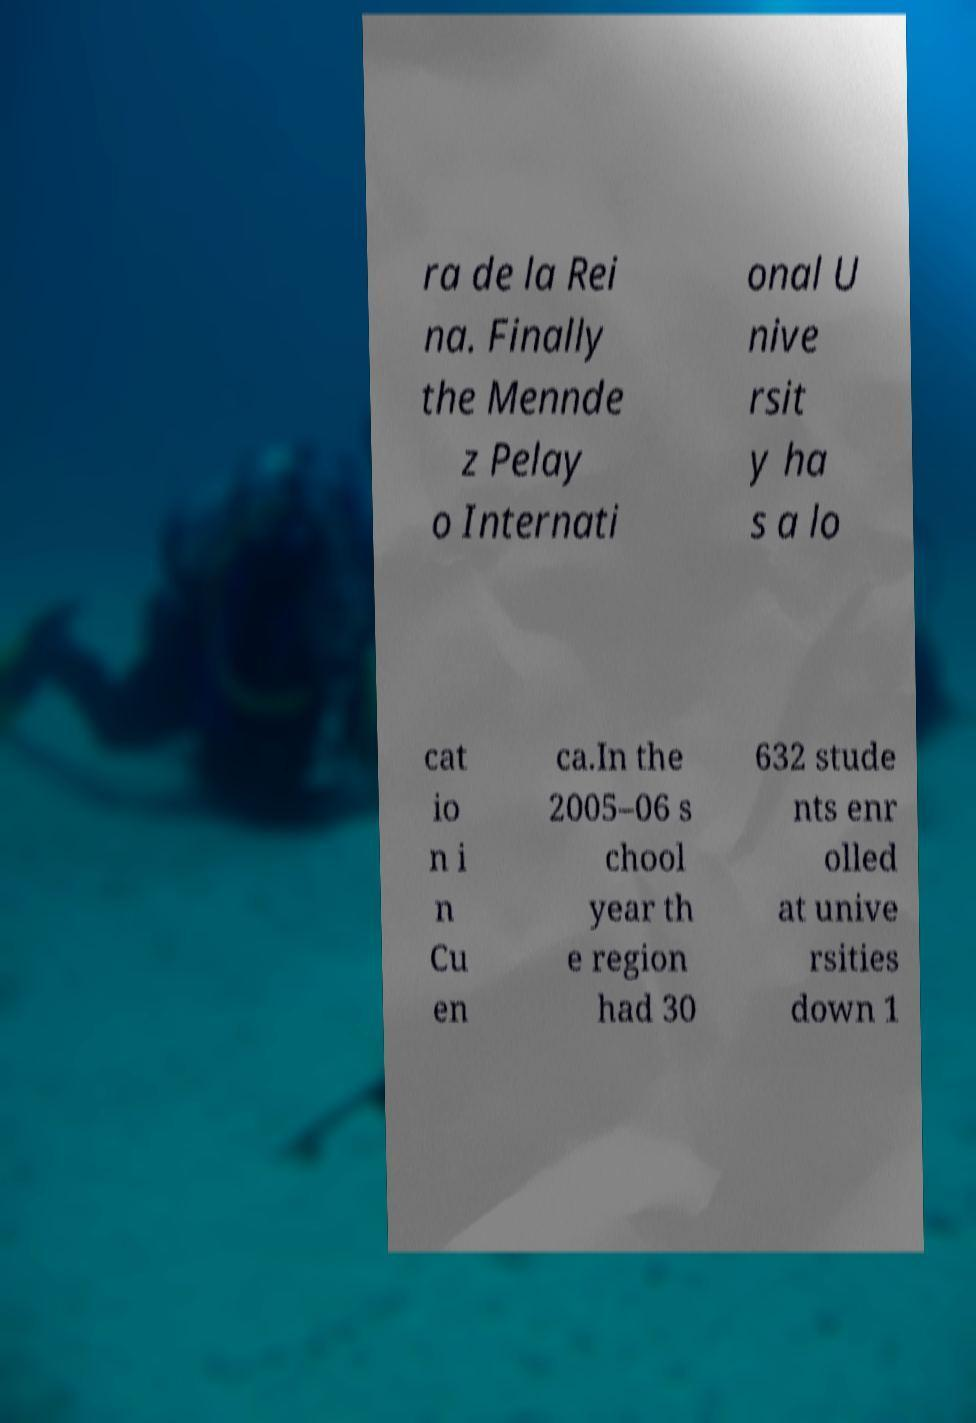Can you read and provide the text displayed in the image?This photo seems to have some interesting text. Can you extract and type it out for me? ra de la Rei na. Finally the Mennde z Pelay o Internati onal U nive rsit y ha s a lo cat io n i n Cu en ca.In the 2005–06 s chool year th e region had 30 632 stude nts enr olled at unive rsities down 1 